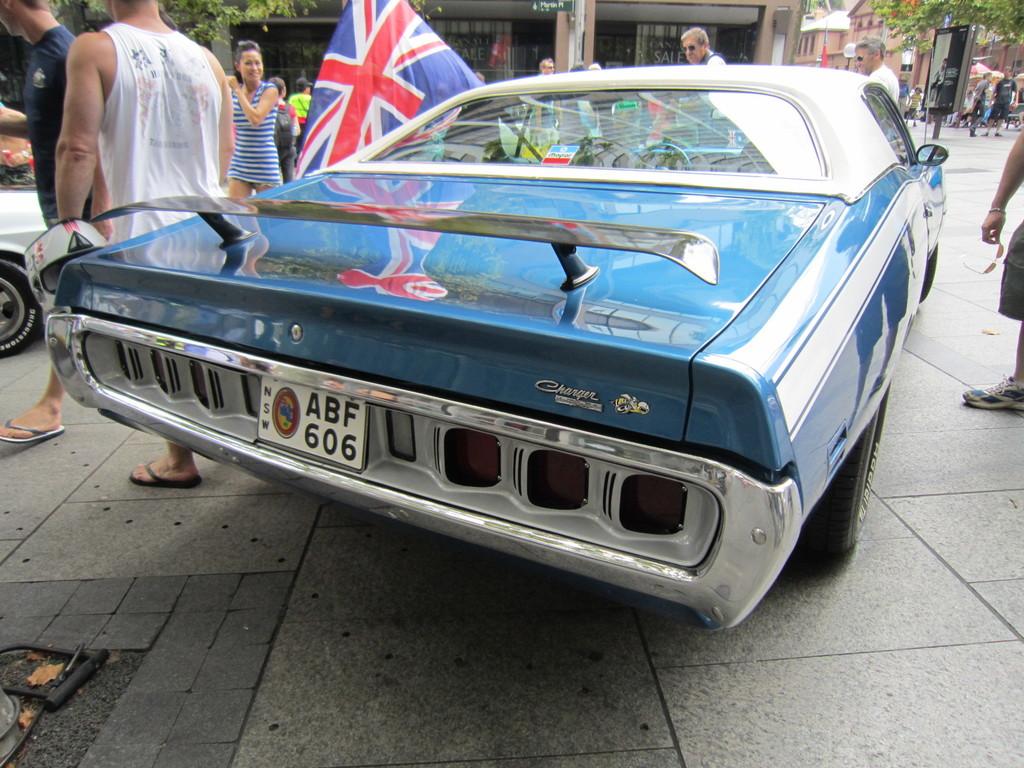What is the license plate number?
Your answer should be very brief. Abf 606. What model of car is this?
Provide a succinct answer. Charger. 